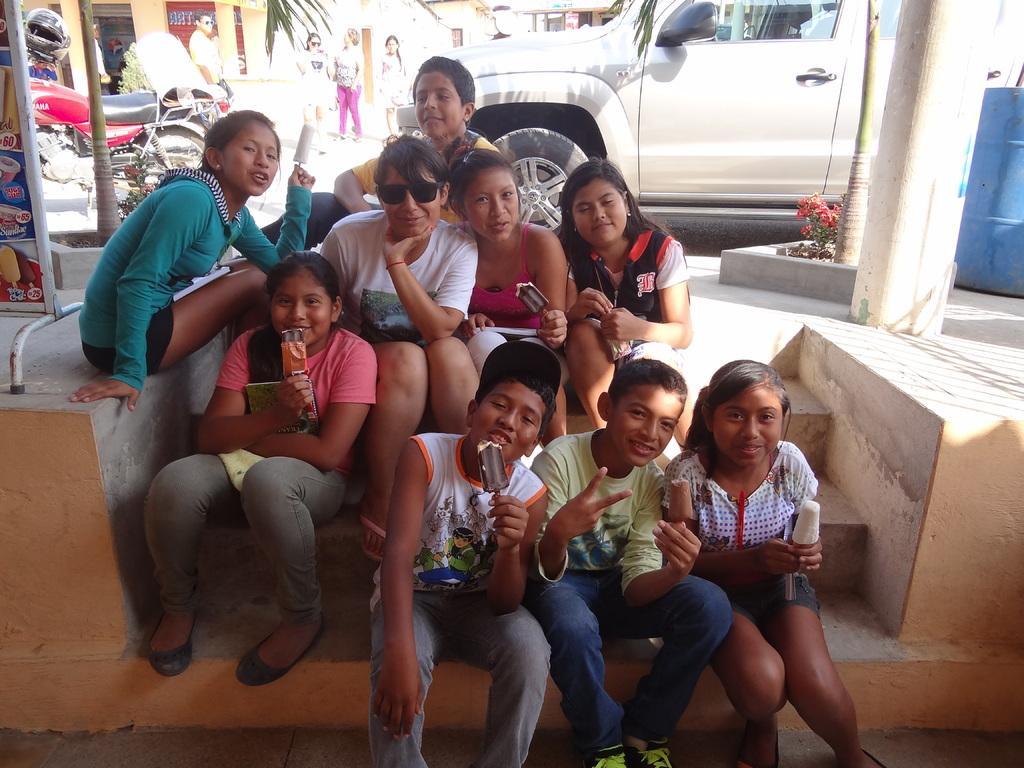Please provide a concise description of this image. In this image, we can see people sitting on the stairs and are holding ice cream bars in the background, there are vehicles, boards, people, trees and some plants and there is a pillar and a drum and we can see some sheds. 